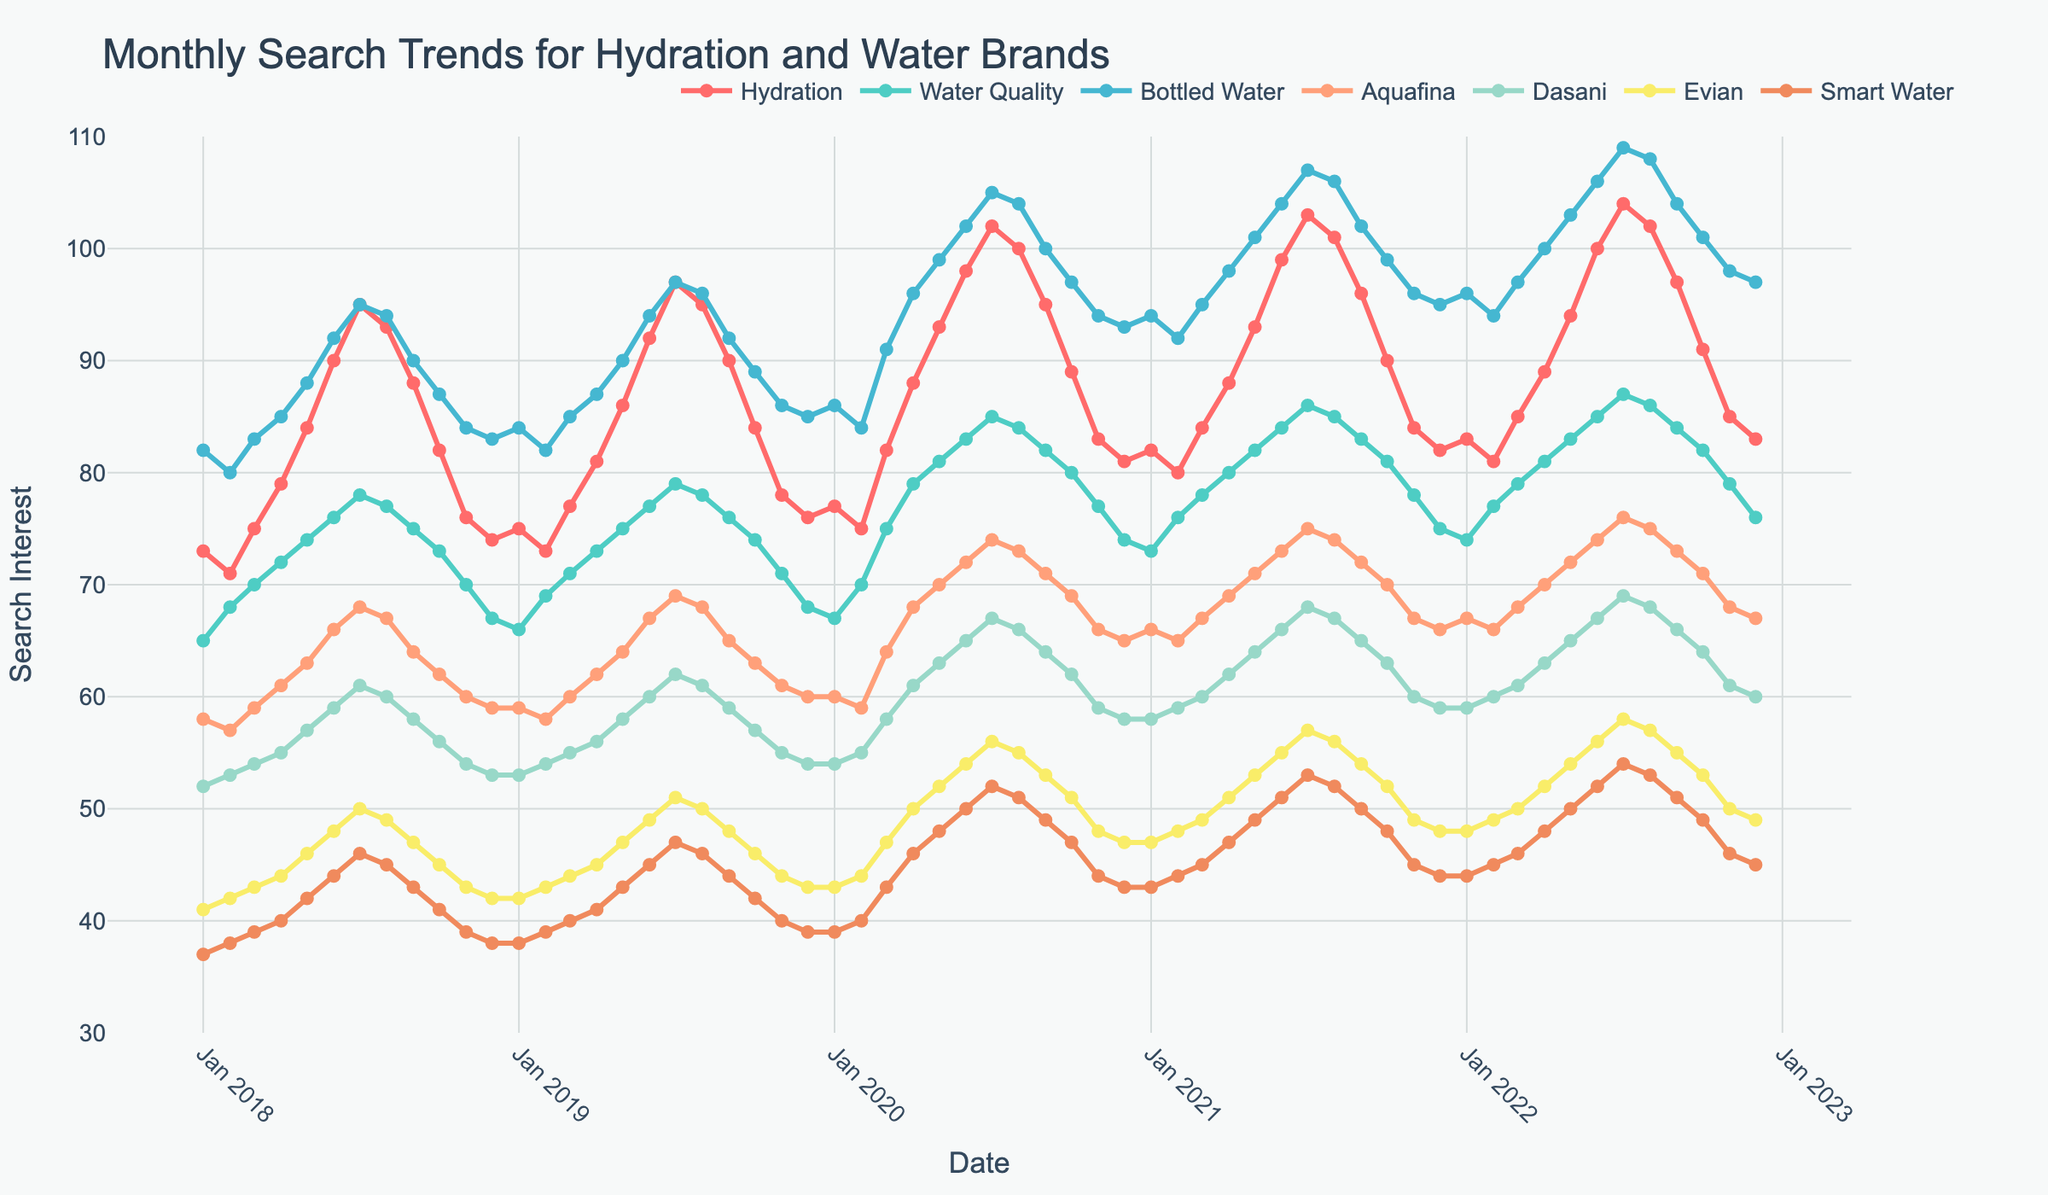Which keyword had the highest overall search interest in July 2021? Look at the line chart for July 2021. Identify the keyword with the highest data point.
Answer: Bottled Water How does the search trend for "Evian" in December 2022 compare to "Dasani" in the same month? Compare the data points for Evian and Dasani in December 2022 from the chart.
Answer: Higher Which month in 2018 had the lowest search interest for "Water Quality"? Check all data points for "Water Quality" in 2018. Determine the month corresponding to the lowest value.
Answer: January What was the average search interest for "Hydration" in the entire year of 2019? Sum the monthly search interest values for "Hydration" in 2019 and divide by 12. (75+73+77+81+86+92+97+95+90+84+78+76)/12 = 83.25
Answer: 83.25 Is the search interest for "Smart Water" decreasing, increasing, or stable over the 5-year period? Observe the general trend of the "Smart Water" line across the 5 years.
Answer: Increasing When did "Aquafina" see its highest search interest, and what was the value? Identify the peak value in the "Aquafina" data and note the corresponding month and year.
Answer: July 2022, 76 Are there any months where "Hydration" and "Water Quality" have the same search interest? If so, which ones? Check the data points to find any months where the values for "Hydration" and "Water Quality" are the same.
Answer: No Which keyword showed the greatest increase in search interest from January 2020 to July 2020? Calculate the difference between January 2020 and July 2020 for all keywords, then identify the largest positive change.
Answer: Hydration What trend can be observed for "Bottled Water" search interest during the summer (June, July, August) months of 2021? Look at the search interest values for "Bottled Water" in June, July, and August 2021.
Answer: Increasing How did the search interest for "Smart Water" in March 2020 compare to March 2021? Compare the data points for "Smart Water" in March 2020 and March 2021.
Answer: Higher 